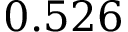<formula> <loc_0><loc_0><loc_500><loc_500>0 . 5 2 6</formula> 